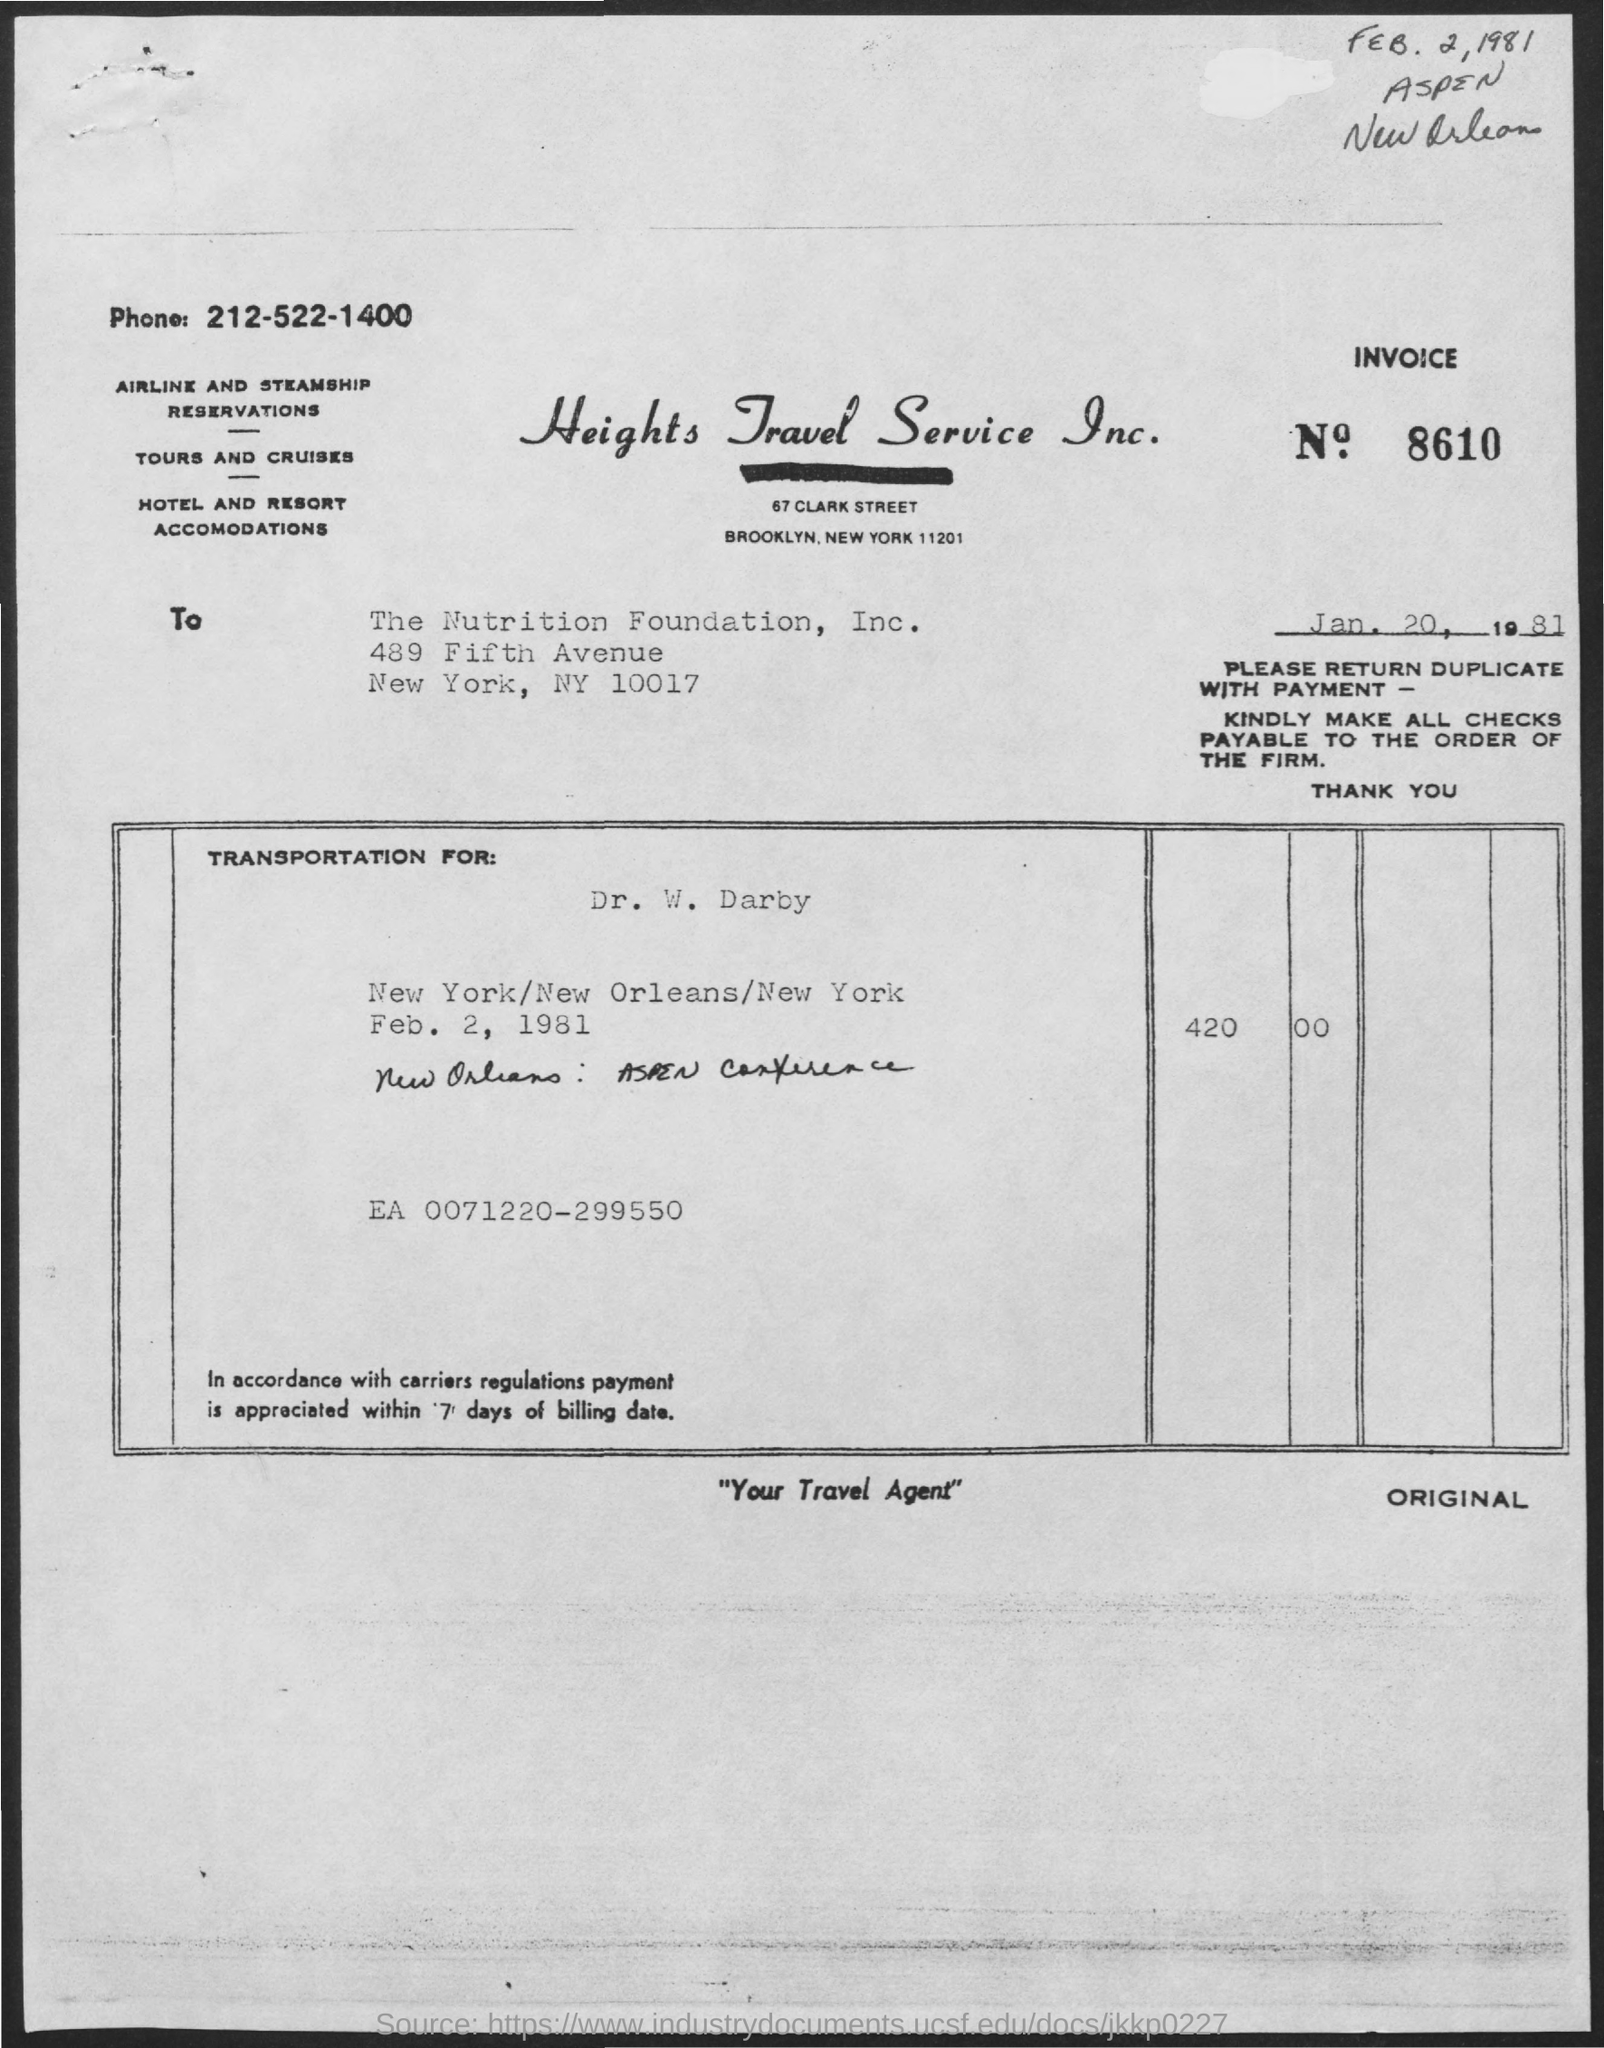List a handful of essential elements in this visual. The handwritten date at the top right of the document is "February 2, 1981. The invoice number is 8610. The invoice number on the document below is January 20, 1981. 